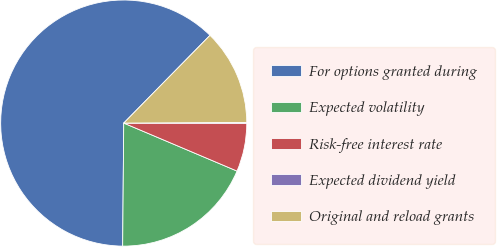Convert chart. <chart><loc_0><loc_0><loc_500><loc_500><pie_chart><fcel>For options granted during<fcel>Expected volatility<fcel>Risk-free interest rate<fcel>Expected dividend yield<fcel>Original and reload grants<nl><fcel>62.23%<fcel>18.76%<fcel>6.34%<fcel>0.12%<fcel>12.55%<nl></chart> 